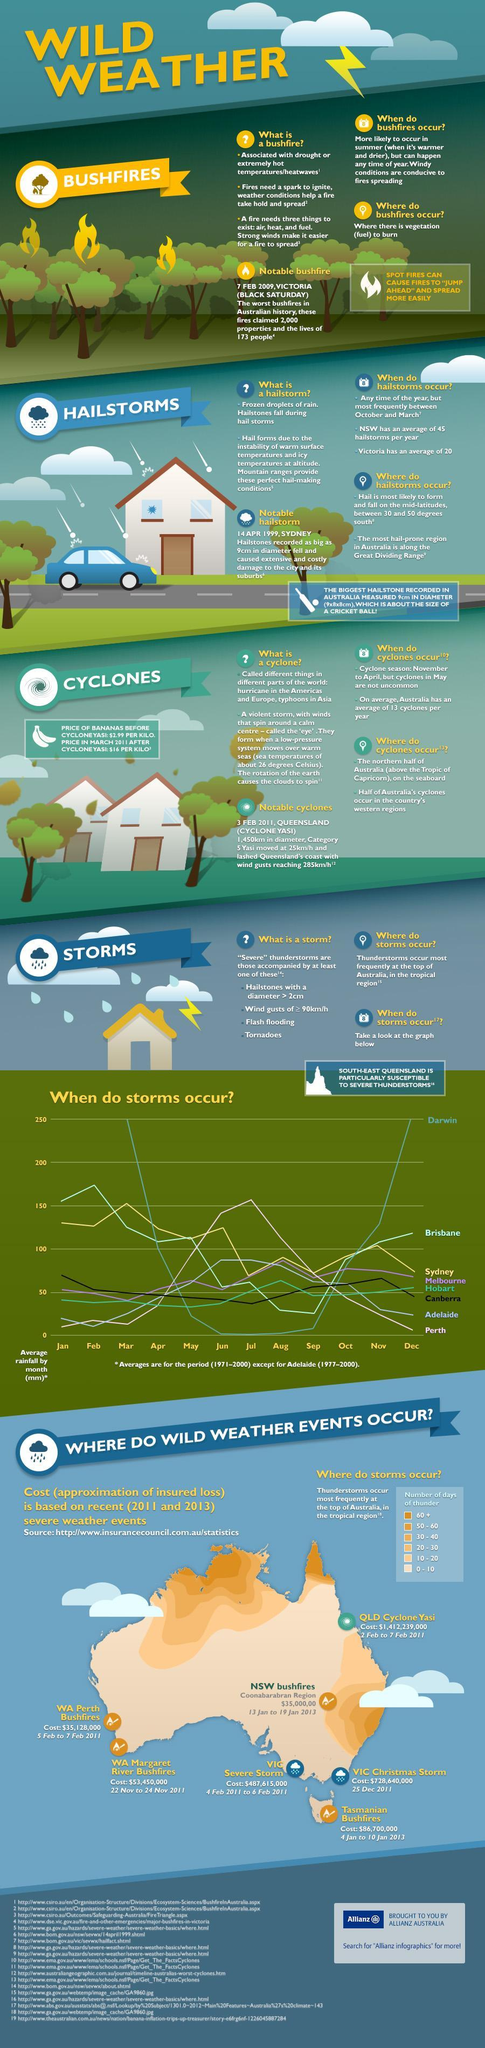In which year Australia witnessed VIC Christmas storm?
Answer the question with a short phrase. 2011 In how many cities of Australia average rainfall crosses the 150 margin? 4 How much was the cost of VIC severe storm? $487,615,000 How much was the loss of WA Perth Bushfires? $35,128,000 In which month of the period Hobart gets highest no of storms? Aug In which city of Australia thunderstorms are at its highest peak? Darwin In which month of the period Brisbane gets highest no of storms? Feb How many days of thunder is experiencing in the Tropical region of Australia? 60+ In which month of the period Sydney gets highest no of storms? Mar In which month of the period Perth gets lowest no of storms? Jan 